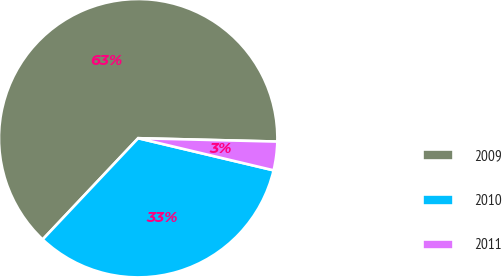Convert chart to OTSL. <chart><loc_0><loc_0><loc_500><loc_500><pie_chart><fcel>2009<fcel>2010<fcel>2011<nl><fcel>63.35%<fcel>33.33%<fcel>3.32%<nl></chart> 